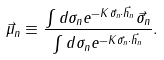Convert formula to latex. <formula><loc_0><loc_0><loc_500><loc_500>\vec { \mu } _ { n } \equiv \frac { \int d \sigma _ { n } e ^ { - K \vec { \sigma } _ { n } \cdot \vec { h } _ { n } } \vec { \sigma } _ { n } } { \int d \sigma _ { n } e ^ { - K \vec { \sigma } _ { n } \cdot \vec { h } _ { n } } } .</formula> 